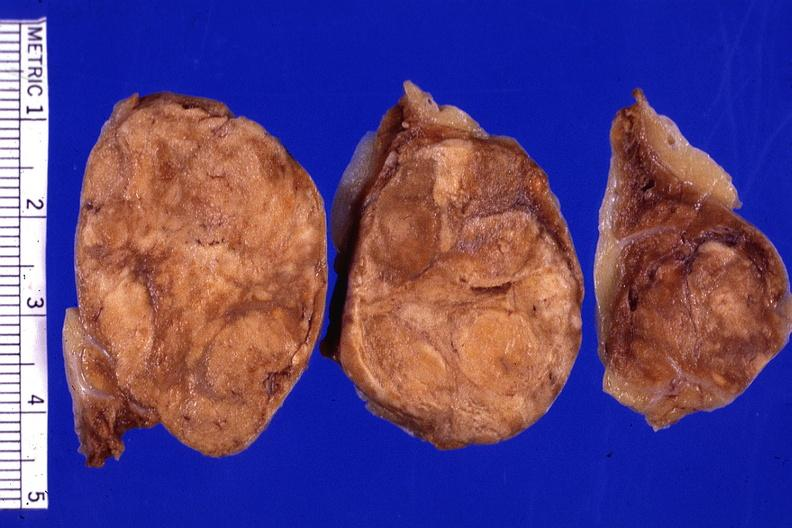s notochord present?
Answer the question using a single word or phrase. No 